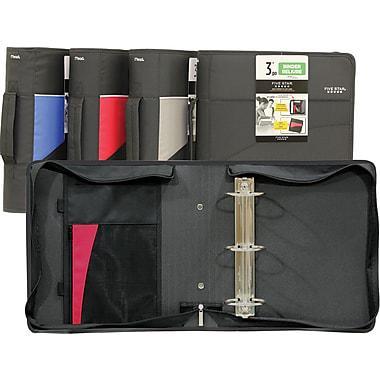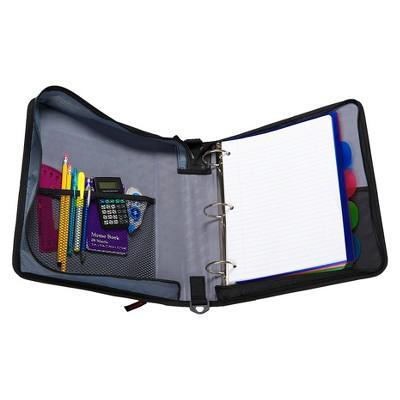The first image is the image on the left, the second image is the image on the right. Assess this claim about the two images: "Each image includes one open ring binder, and at least one of the binders pictured is filled with paper and other supplies.". Correct or not? Answer yes or no. Yes. The first image is the image on the left, the second image is the image on the right. Given the left and right images, does the statement "There are writing utensils inside a mesh compartment." hold true? Answer yes or no. Yes. 